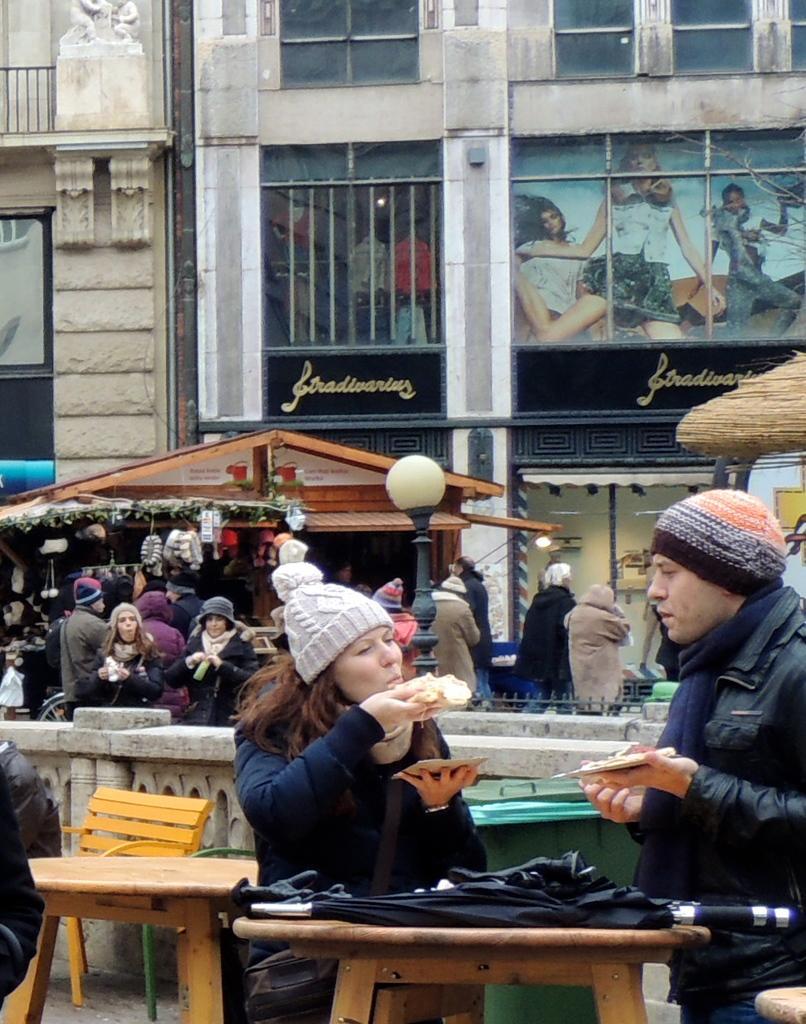How would you summarize this image in a sentence or two? This is a picture taken in the outdoor, the two people the man and the women are sitting on the chairs in front of them there is a table on the table there is a umbrella. Backside of the two people there is a building with a poster of three people. 